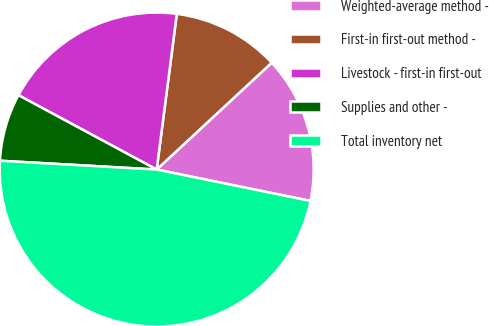Convert chart to OTSL. <chart><loc_0><loc_0><loc_500><loc_500><pie_chart><fcel>Weighted-average method -<fcel>First-in first-out method -<fcel>Livestock - first-in first-out<fcel>Supplies and other -<fcel>Total inventory net<nl><fcel>15.12%<fcel>11.04%<fcel>19.19%<fcel>6.96%<fcel>47.69%<nl></chart> 